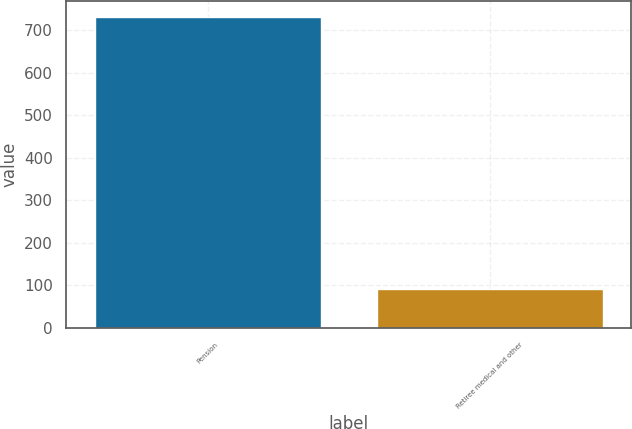Convert chart to OTSL. <chart><loc_0><loc_0><loc_500><loc_500><bar_chart><fcel>Pension<fcel>Retiree medical and other<nl><fcel>732<fcel>91<nl></chart> 